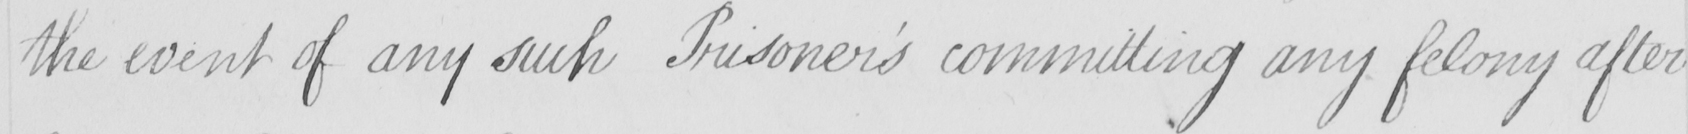Can you read and transcribe this handwriting? the event of any such Prisoner ' s committing any felony after 